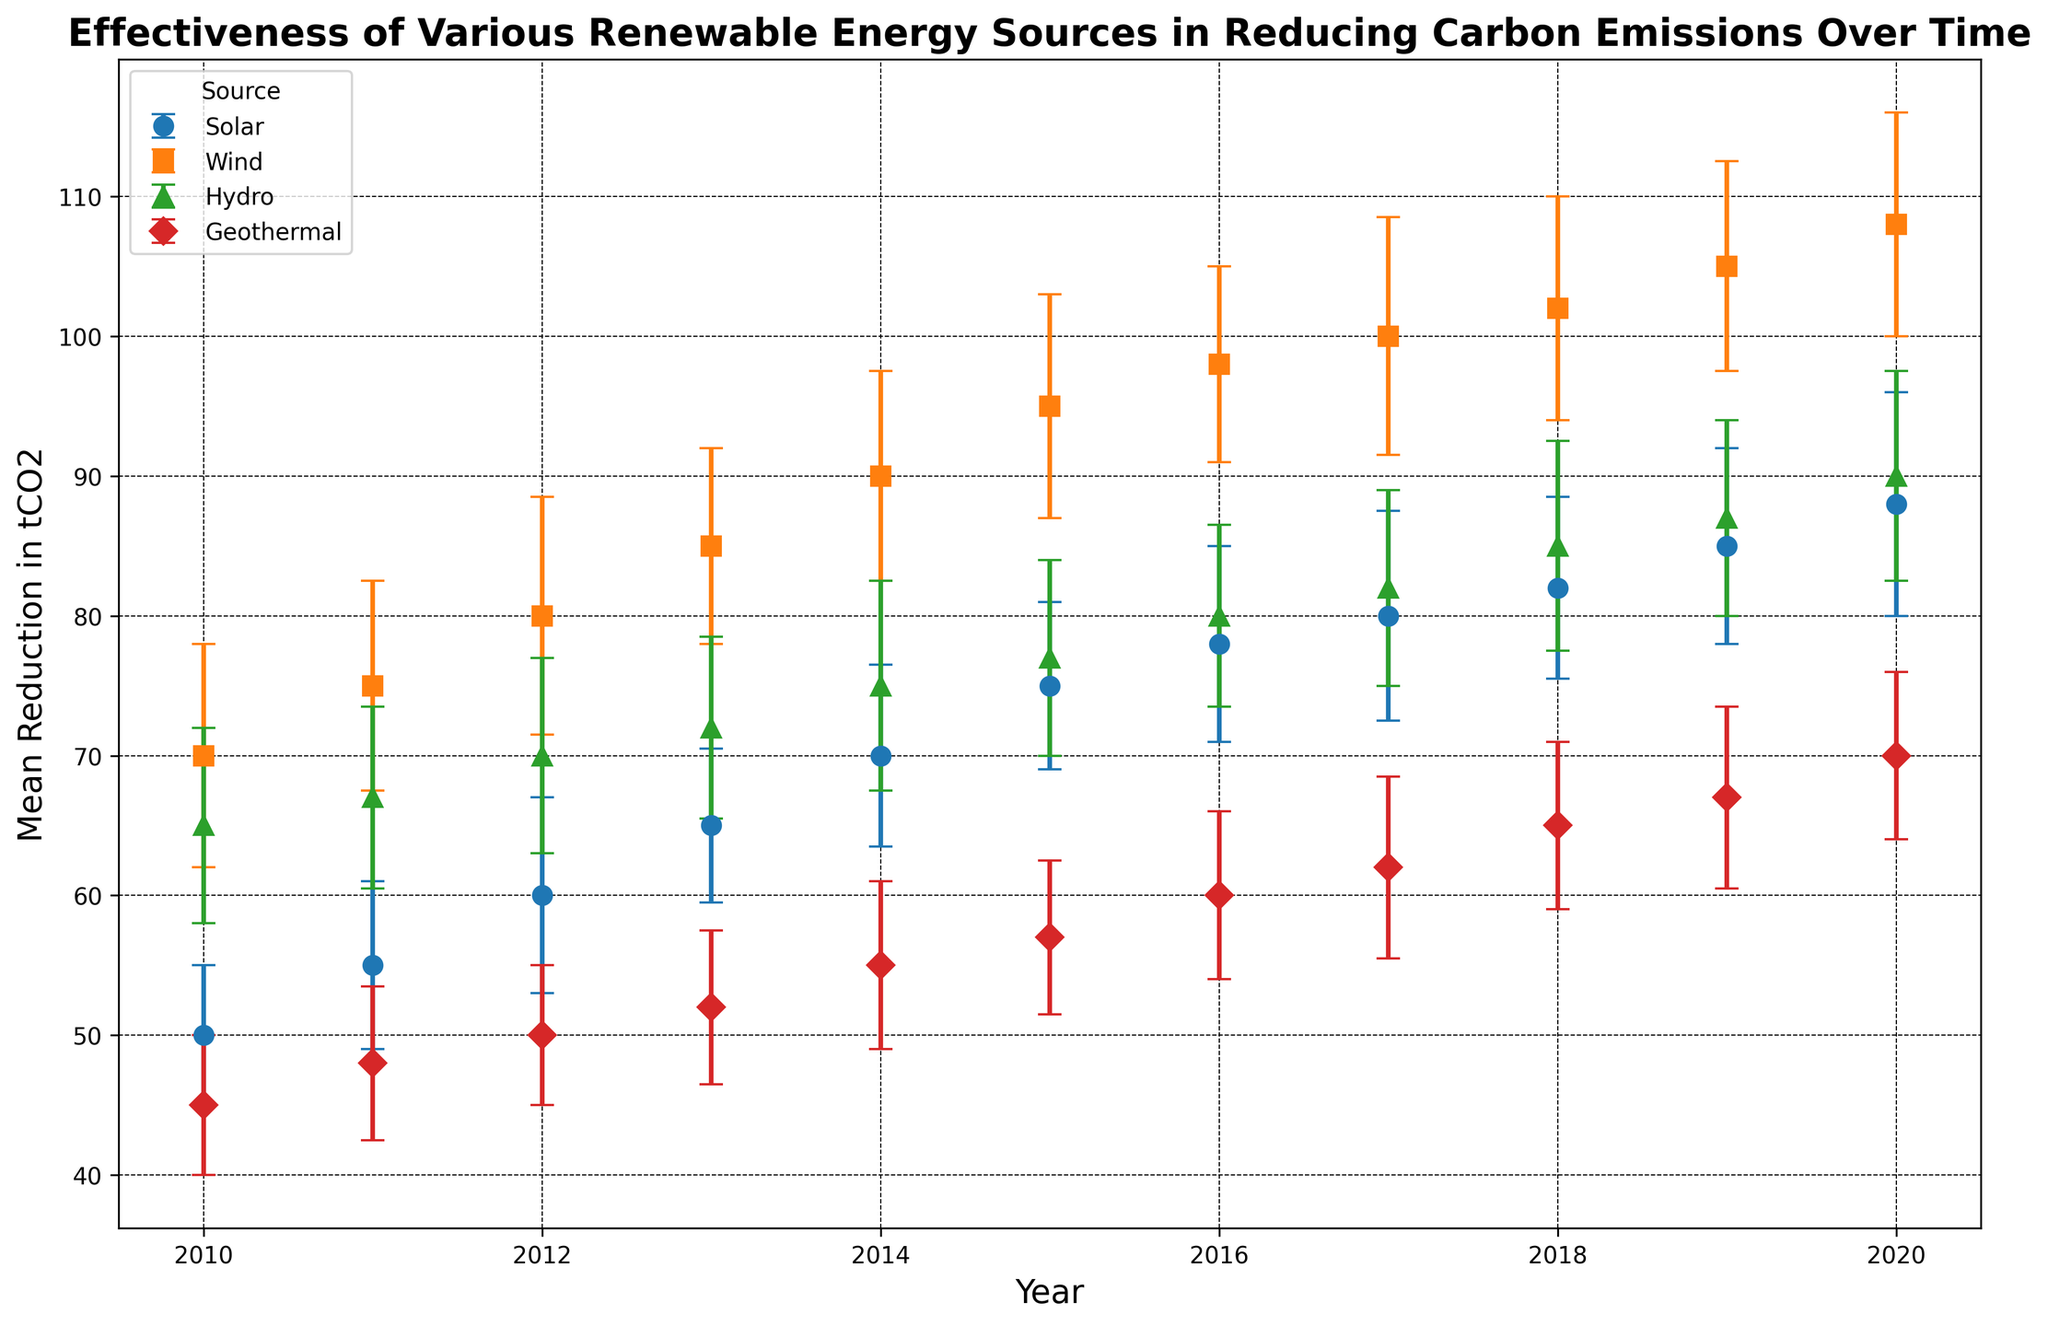What is the general trend observed in the effectiveness of Solar energy in reducing carbon emissions from 2010 to 2020? From 2010 to 2020, the mean reduction in tCO2 for Solar energy increases every year, indicating a positive trend i.e., the effectiveness of Solar energy in reducing carbon emissions improves over the years.
Answer: It is an increasing trend Which renewable energy source shows the highest mean reduction in carbon emissions by 2020? By 2020, Wind energy shows the highest mean reduction in tCO2, reaching up to 108 tCO2. This can be observed by comparing the end points of the lines representing each energy source in the graph.
Answer: Wind energy How does the reduction in carbon emissions in 2015 compare between Solar and Hydro energy? In 2015, the mean reduction in tCO2 for Solar is 75 while for Hydro it is 77. Comparing these two values, Hydro has a slightly higher reduction in carbon emissions compared to Solar.
Answer: Hydro is higher Considering 2012 data, which renewable energy source has the highest variability in carbon emission reduction, and how do you know? In 2012, Wind energy has the highest error bar representing the standard deviation at 8.5 tCO2, indicating the highest variability among the four sources.
Answer: Wind energy Calculate the average mean reduction for Geothermal energy from 2010 to 2020. Sum the reductions: 45 + 48 + 50 + 52 + 55 + 57 + 60 + 62 + 65 + 67 + 70 = 631. Count the years: 11. Average mean reduction: 631 / 11 = 57.36 tCO2
Answer: 57.36 tCO2 Between which consecutive years does Wind energy show the highest increase in the mean reduction of carbon emissions? The increase in mean reduction for each consecutive year needs to be calculated. The highest increase is between 2014 and 2015, where the mean reduction rises from 90 to 95, giving an increase of 5 tCO2, which is the maximum observed.
Answer: 2014 to 2015 What is the difference in mean reduction of tCO2 between Wind energy and Geothermal energy in 2017? In 2017, the mean reduction for Wind is 100, and for Geothermal, it is 62. The difference: 100 - 62 = 38 tCO2.
Answer: 38 tCO2 Which year does Solar energy show the smallest standard deviation in carbon emission reduction, and what is the value? The smallest standard deviation for Solar energy in the provided data occurs in 2010, where it is 5.
Answer: 2010, value of 5 By what amount does Hydro energy's mean reduction in tCO2 increase from 2018 to 2020? In 2018 the reduction is 85, and in 2020 it is 90. The increase is 90 - 85 = 5 tCO2.
Answer: 5 tCO2 In 2013, which renewable energy source has the closest mean reduction value to 70 tCO2? The sources with mean reductions in 2013 are Solar (65 tCO2), Wind (85 tCO2), Hydro (72 tCO2), Geothermal (52 tCO2). Hydro's mean reduction of 72 tCO2 is closest to 70 tCO2.
Answer: Hydro 